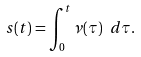<formula> <loc_0><loc_0><loc_500><loc_500>s ( t ) = \int _ { 0 } ^ { t } \nu ( \tau ) \ d \tau .</formula> 